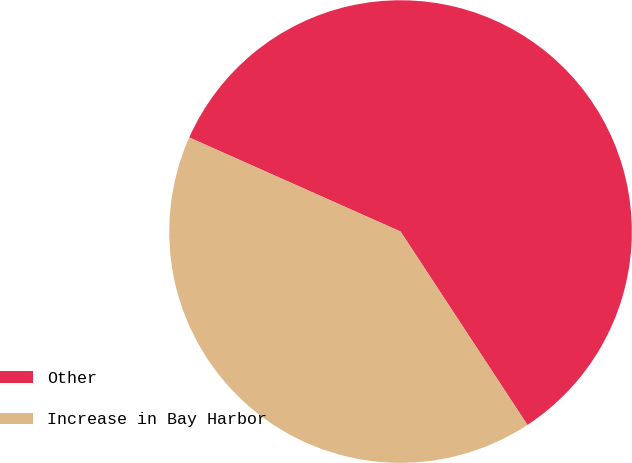<chart> <loc_0><loc_0><loc_500><loc_500><pie_chart><fcel>Other<fcel>Increase in Bay Harbor<nl><fcel>59.09%<fcel>40.91%<nl></chart> 